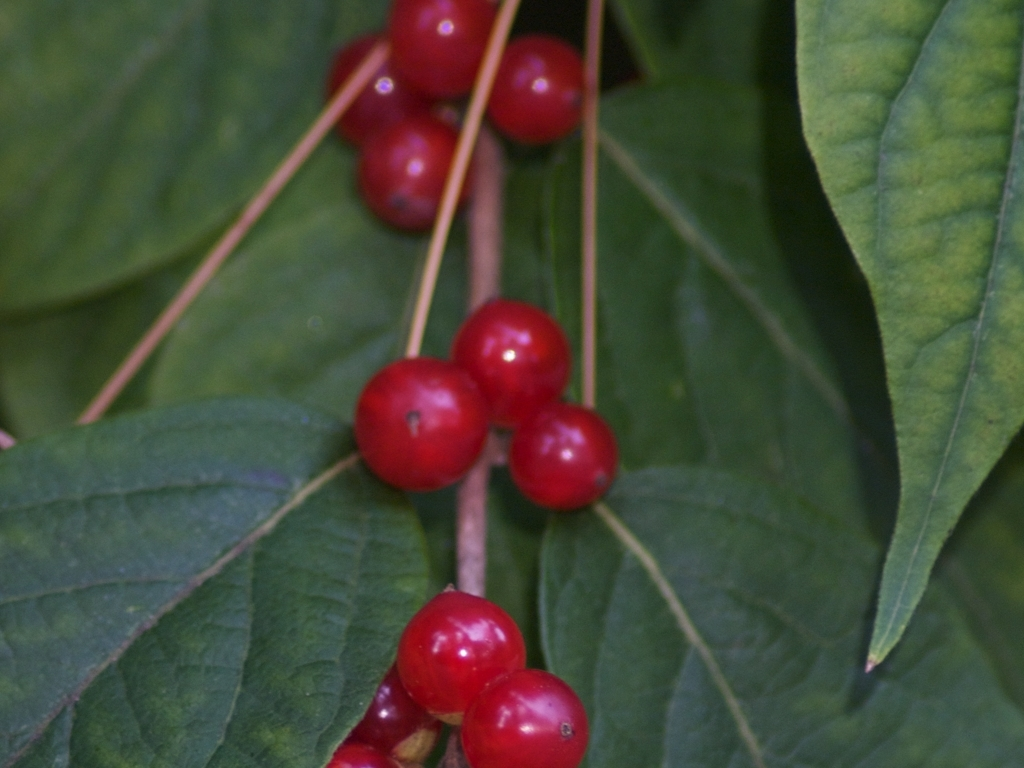What kind of plant is this? The plant in the image appears to be a type of berry-producing shrub. The leaves have a recognizable shape that is somewhat ovate with a pointed tip. To identify the plant accurately, one would need to consider its characteristics more closely or consult a botanical reference. 